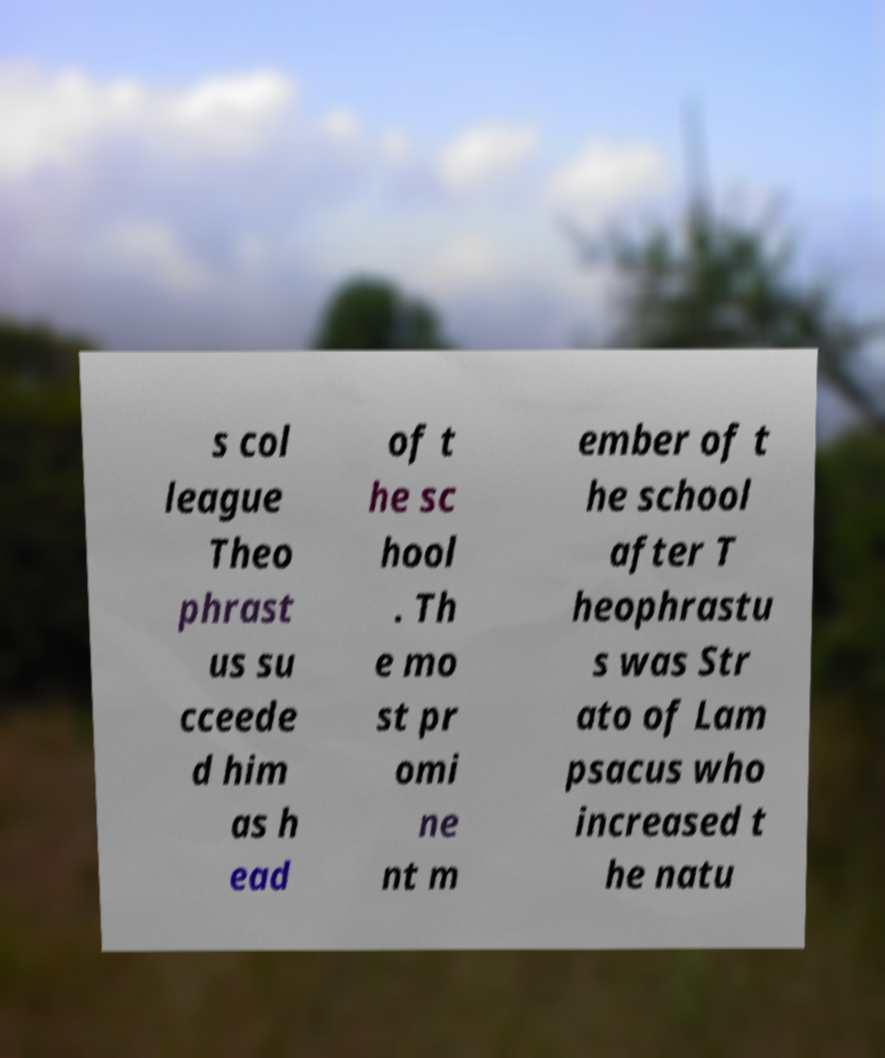Can you read and provide the text displayed in the image?This photo seems to have some interesting text. Can you extract and type it out for me? s col league Theo phrast us su cceede d him as h ead of t he sc hool . Th e mo st pr omi ne nt m ember of t he school after T heophrastu s was Str ato of Lam psacus who increased t he natu 